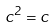<formula> <loc_0><loc_0><loc_500><loc_500>c ^ { 2 } = c</formula> 